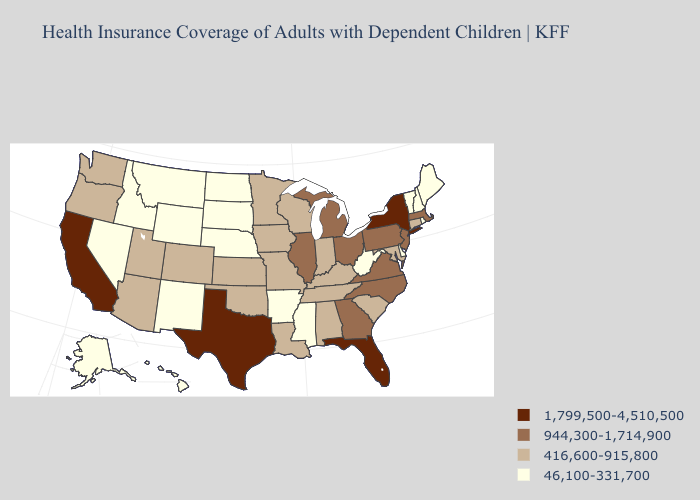Which states have the highest value in the USA?
Answer briefly. California, Florida, New York, Texas. Does Tennessee have a lower value than Texas?
Give a very brief answer. Yes. Does Maryland have the lowest value in the South?
Give a very brief answer. No. Among the states that border New Jersey , which have the highest value?
Answer briefly. New York. What is the lowest value in states that border Louisiana?
Answer briefly. 46,100-331,700. What is the value of Maine?
Be succinct. 46,100-331,700. What is the value of New Mexico?
Answer briefly. 46,100-331,700. Name the states that have a value in the range 944,300-1,714,900?
Short answer required. Georgia, Illinois, Massachusetts, Michigan, New Jersey, North Carolina, Ohio, Pennsylvania, Virginia. What is the value of North Dakota?
Answer briefly. 46,100-331,700. Does the first symbol in the legend represent the smallest category?
Answer briefly. No. Does Colorado have a lower value than South Carolina?
Keep it brief. No. What is the value of West Virginia?
Short answer required. 46,100-331,700. Among the states that border Wyoming , does Colorado have the highest value?
Concise answer only. Yes. What is the value of Maryland?
Quick response, please. 416,600-915,800. Name the states that have a value in the range 416,600-915,800?
Keep it brief. Alabama, Arizona, Colorado, Connecticut, Indiana, Iowa, Kansas, Kentucky, Louisiana, Maryland, Minnesota, Missouri, Oklahoma, Oregon, South Carolina, Tennessee, Utah, Washington, Wisconsin. 